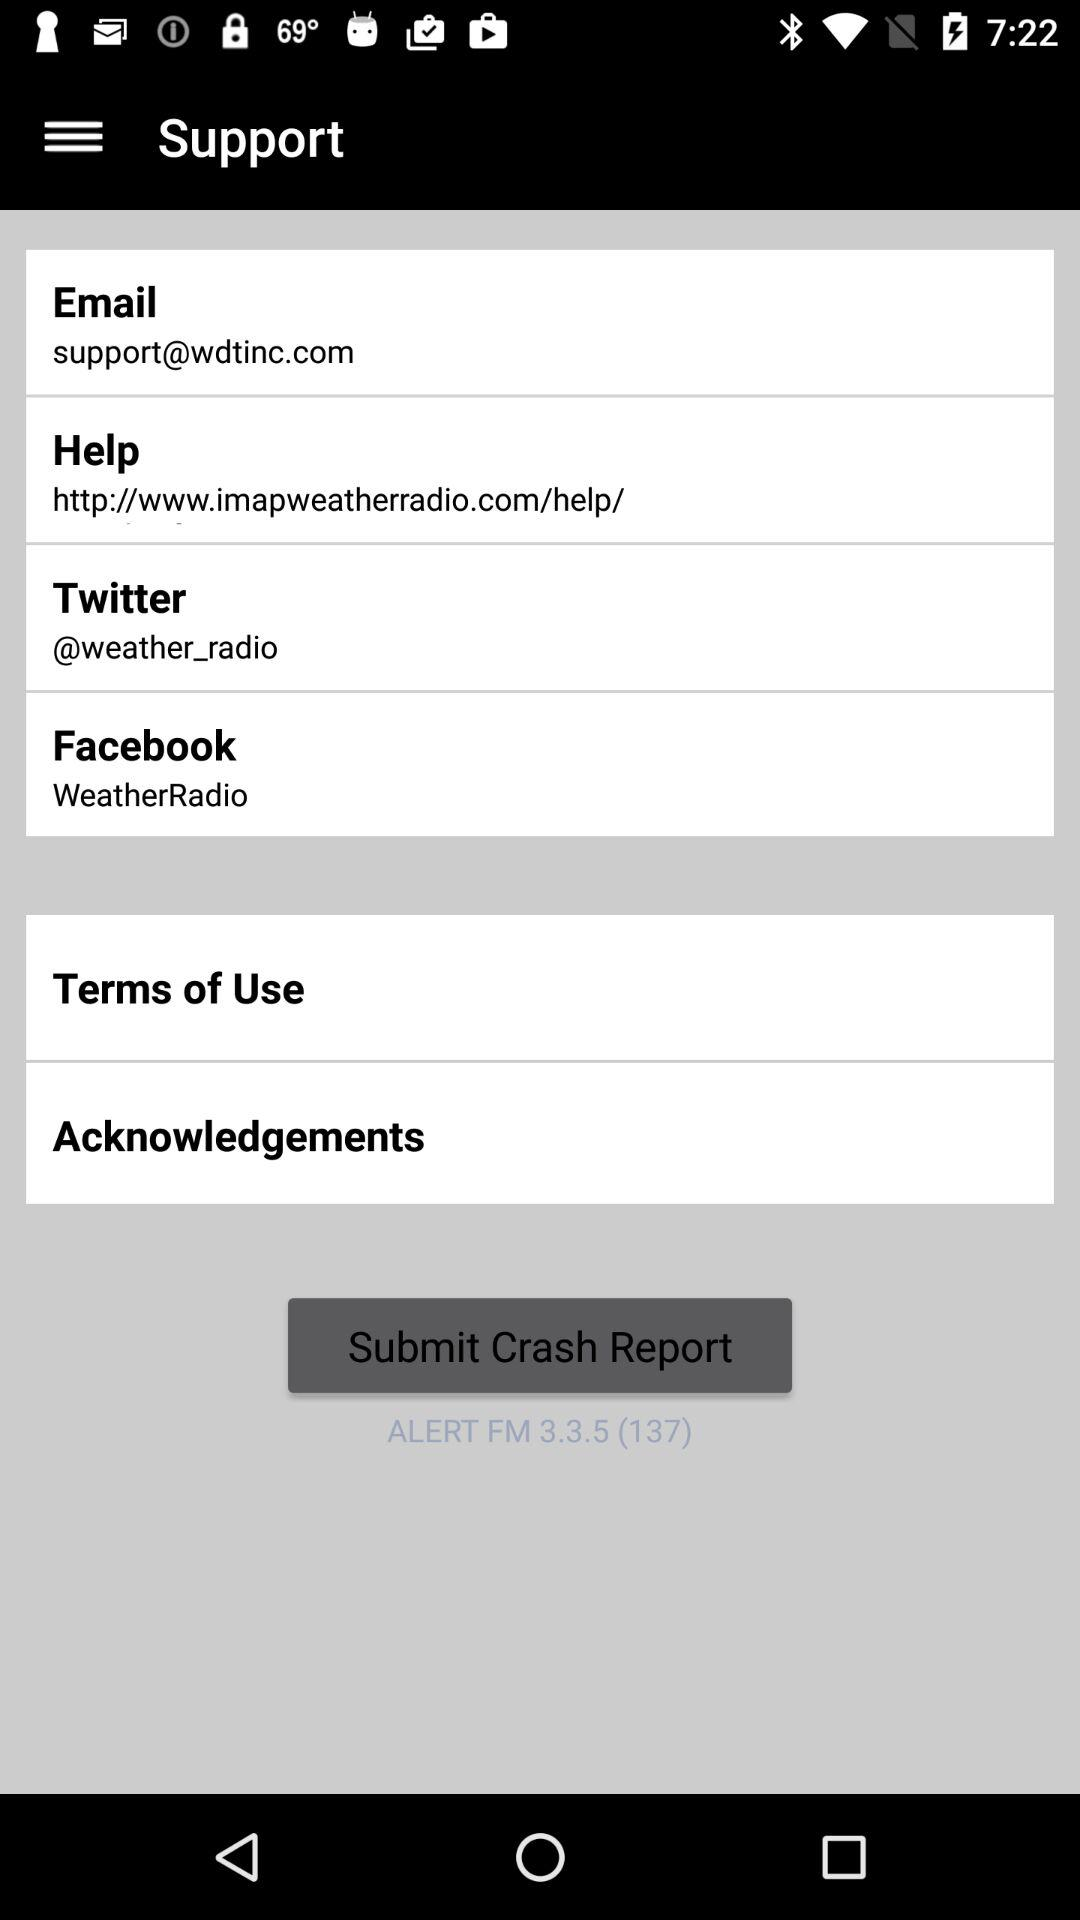Where will the crash report be submitted to?
When the provided information is insufficient, respond with <no answer>. <no answer> 